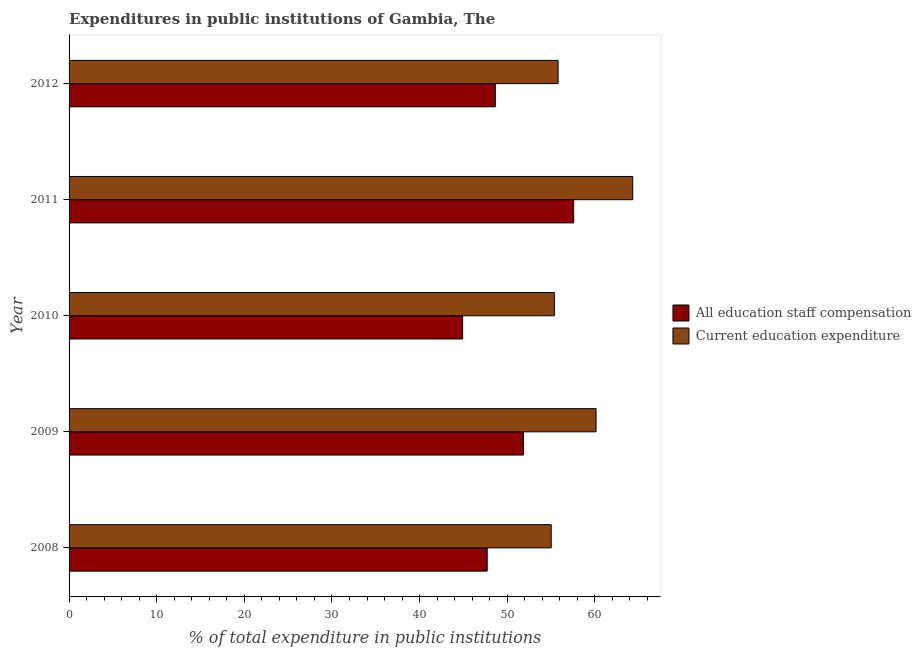How many different coloured bars are there?
Keep it short and to the point. 2. How many groups of bars are there?
Keep it short and to the point. 5. Are the number of bars per tick equal to the number of legend labels?
Ensure brevity in your answer.  Yes. Are the number of bars on each tick of the Y-axis equal?
Make the answer very short. Yes. How many bars are there on the 2nd tick from the top?
Your answer should be very brief. 2. How many bars are there on the 5th tick from the bottom?
Your answer should be compact. 2. In how many cases, is the number of bars for a given year not equal to the number of legend labels?
Ensure brevity in your answer.  0. What is the expenditure in staff compensation in 2010?
Offer a terse response. 44.91. Across all years, what is the maximum expenditure in education?
Offer a terse response. 64.33. Across all years, what is the minimum expenditure in staff compensation?
Your response must be concise. 44.91. In which year was the expenditure in staff compensation minimum?
Make the answer very short. 2010. What is the total expenditure in education in the graph?
Offer a very short reply. 290.68. What is the difference between the expenditure in education in 2008 and that in 2010?
Offer a terse response. -0.36. What is the difference between the expenditure in staff compensation in 2011 and the expenditure in education in 2012?
Your response must be concise. 1.78. What is the average expenditure in education per year?
Offer a terse response. 58.14. In the year 2008, what is the difference between the expenditure in education and expenditure in staff compensation?
Offer a terse response. 7.31. What is the ratio of the expenditure in education in 2009 to that in 2012?
Make the answer very short. 1.08. Is the expenditure in education in 2009 less than that in 2011?
Provide a succinct answer. Yes. Is the difference between the expenditure in staff compensation in 2008 and 2012 greater than the difference between the expenditure in education in 2008 and 2012?
Make the answer very short. No. What is the difference between the highest and the second highest expenditure in education?
Your response must be concise. 4.19. What is the difference between the highest and the lowest expenditure in staff compensation?
Offer a terse response. 12.67. In how many years, is the expenditure in education greater than the average expenditure in education taken over all years?
Your response must be concise. 2. Is the sum of the expenditure in education in 2010 and 2011 greater than the maximum expenditure in staff compensation across all years?
Provide a succinct answer. Yes. What does the 2nd bar from the top in 2008 represents?
Your response must be concise. All education staff compensation. What does the 2nd bar from the bottom in 2010 represents?
Make the answer very short. Current education expenditure. How many bars are there?
Keep it short and to the point. 10. Are all the bars in the graph horizontal?
Provide a short and direct response. Yes. How many years are there in the graph?
Your answer should be very brief. 5. What is the difference between two consecutive major ticks on the X-axis?
Ensure brevity in your answer.  10. Does the graph contain any zero values?
Your answer should be very brief. No. Does the graph contain grids?
Your response must be concise. No. Where does the legend appear in the graph?
Keep it short and to the point. Center right. How are the legend labels stacked?
Offer a very short reply. Vertical. What is the title of the graph?
Your answer should be very brief. Expenditures in public institutions of Gambia, The. What is the label or title of the X-axis?
Your answer should be very brief. % of total expenditure in public institutions. What is the % of total expenditure in public institutions in All education staff compensation in 2008?
Provide a succinct answer. 47.71. What is the % of total expenditure in public institutions in Current education expenditure in 2008?
Your response must be concise. 55.02. What is the % of total expenditure in public institutions in All education staff compensation in 2009?
Your response must be concise. 51.85. What is the % of total expenditure in public institutions of Current education expenditure in 2009?
Your response must be concise. 60.14. What is the % of total expenditure in public institutions in All education staff compensation in 2010?
Provide a succinct answer. 44.91. What is the % of total expenditure in public institutions in Current education expenditure in 2010?
Your response must be concise. 55.38. What is the % of total expenditure in public institutions of All education staff compensation in 2011?
Offer a terse response. 57.58. What is the % of total expenditure in public institutions of Current education expenditure in 2011?
Provide a succinct answer. 64.33. What is the % of total expenditure in public institutions of All education staff compensation in 2012?
Ensure brevity in your answer.  48.64. What is the % of total expenditure in public institutions in Current education expenditure in 2012?
Provide a short and direct response. 55.81. Across all years, what is the maximum % of total expenditure in public institutions in All education staff compensation?
Keep it short and to the point. 57.58. Across all years, what is the maximum % of total expenditure in public institutions of Current education expenditure?
Give a very brief answer. 64.33. Across all years, what is the minimum % of total expenditure in public institutions of All education staff compensation?
Make the answer very short. 44.91. Across all years, what is the minimum % of total expenditure in public institutions of Current education expenditure?
Offer a terse response. 55.02. What is the total % of total expenditure in public institutions of All education staff compensation in the graph?
Provide a succinct answer. 250.71. What is the total % of total expenditure in public institutions of Current education expenditure in the graph?
Offer a terse response. 290.68. What is the difference between the % of total expenditure in public institutions in All education staff compensation in 2008 and that in 2009?
Provide a short and direct response. -4.14. What is the difference between the % of total expenditure in public institutions in Current education expenditure in 2008 and that in 2009?
Offer a very short reply. -5.11. What is the difference between the % of total expenditure in public institutions in All education staff compensation in 2008 and that in 2010?
Your response must be concise. 2.8. What is the difference between the % of total expenditure in public institutions in Current education expenditure in 2008 and that in 2010?
Your answer should be compact. -0.36. What is the difference between the % of total expenditure in public institutions in All education staff compensation in 2008 and that in 2011?
Ensure brevity in your answer.  -9.87. What is the difference between the % of total expenditure in public institutions of Current education expenditure in 2008 and that in 2011?
Offer a very short reply. -9.3. What is the difference between the % of total expenditure in public institutions in All education staff compensation in 2008 and that in 2012?
Make the answer very short. -0.93. What is the difference between the % of total expenditure in public institutions of Current education expenditure in 2008 and that in 2012?
Your response must be concise. -0.78. What is the difference between the % of total expenditure in public institutions in All education staff compensation in 2009 and that in 2010?
Offer a terse response. 6.94. What is the difference between the % of total expenditure in public institutions of Current education expenditure in 2009 and that in 2010?
Ensure brevity in your answer.  4.75. What is the difference between the % of total expenditure in public institutions of All education staff compensation in 2009 and that in 2011?
Your answer should be compact. -5.73. What is the difference between the % of total expenditure in public institutions in Current education expenditure in 2009 and that in 2011?
Your answer should be compact. -4.19. What is the difference between the % of total expenditure in public institutions in All education staff compensation in 2009 and that in 2012?
Offer a terse response. 3.21. What is the difference between the % of total expenditure in public institutions in Current education expenditure in 2009 and that in 2012?
Offer a very short reply. 4.33. What is the difference between the % of total expenditure in public institutions of All education staff compensation in 2010 and that in 2011?
Keep it short and to the point. -12.67. What is the difference between the % of total expenditure in public institutions of Current education expenditure in 2010 and that in 2011?
Your answer should be compact. -8.94. What is the difference between the % of total expenditure in public institutions of All education staff compensation in 2010 and that in 2012?
Your response must be concise. -3.73. What is the difference between the % of total expenditure in public institutions of Current education expenditure in 2010 and that in 2012?
Your answer should be compact. -0.42. What is the difference between the % of total expenditure in public institutions of All education staff compensation in 2011 and that in 2012?
Offer a terse response. 8.94. What is the difference between the % of total expenditure in public institutions of Current education expenditure in 2011 and that in 2012?
Your answer should be very brief. 8.52. What is the difference between the % of total expenditure in public institutions of All education staff compensation in 2008 and the % of total expenditure in public institutions of Current education expenditure in 2009?
Offer a very short reply. -12.42. What is the difference between the % of total expenditure in public institutions in All education staff compensation in 2008 and the % of total expenditure in public institutions in Current education expenditure in 2010?
Provide a succinct answer. -7.67. What is the difference between the % of total expenditure in public institutions of All education staff compensation in 2008 and the % of total expenditure in public institutions of Current education expenditure in 2011?
Give a very brief answer. -16.61. What is the difference between the % of total expenditure in public institutions of All education staff compensation in 2008 and the % of total expenditure in public institutions of Current education expenditure in 2012?
Your answer should be very brief. -8.09. What is the difference between the % of total expenditure in public institutions of All education staff compensation in 2009 and the % of total expenditure in public institutions of Current education expenditure in 2010?
Ensure brevity in your answer.  -3.53. What is the difference between the % of total expenditure in public institutions in All education staff compensation in 2009 and the % of total expenditure in public institutions in Current education expenditure in 2011?
Offer a very short reply. -12.47. What is the difference between the % of total expenditure in public institutions of All education staff compensation in 2009 and the % of total expenditure in public institutions of Current education expenditure in 2012?
Offer a very short reply. -3.95. What is the difference between the % of total expenditure in public institutions in All education staff compensation in 2010 and the % of total expenditure in public institutions in Current education expenditure in 2011?
Provide a short and direct response. -19.42. What is the difference between the % of total expenditure in public institutions of All education staff compensation in 2010 and the % of total expenditure in public institutions of Current education expenditure in 2012?
Provide a succinct answer. -10.9. What is the difference between the % of total expenditure in public institutions of All education staff compensation in 2011 and the % of total expenditure in public institutions of Current education expenditure in 2012?
Offer a very short reply. 1.78. What is the average % of total expenditure in public institutions in All education staff compensation per year?
Make the answer very short. 50.14. What is the average % of total expenditure in public institutions of Current education expenditure per year?
Keep it short and to the point. 58.14. In the year 2008, what is the difference between the % of total expenditure in public institutions of All education staff compensation and % of total expenditure in public institutions of Current education expenditure?
Make the answer very short. -7.31. In the year 2009, what is the difference between the % of total expenditure in public institutions in All education staff compensation and % of total expenditure in public institutions in Current education expenditure?
Offer a very short reply. -8.28. In the year 2010, what is the difference between the % of total expenditure in public institutions of All education staff compensation and % of total expenditure in public institutions of Current education expenditure?
Your response must be concise. -10.47. In the year 2011, what is the difference between the % of total expenditure in public institutions of All education staff compensation and % of total expenditure in public institutions of Current education expenditure?
Your response must be concise. -6.74. In the year 2012, what is the difference between the % of total expenditure in public institutions of All education staff compensation and % of total expenditure in public institutions of Current education expenditure?
Your response must be concise. -7.16. What is the ratio of the % of total expenditure in public institutions in All education staff compensation in 2008 to that in 2009?
Give a very brief answer. 0.92. What is the ratio of the % of total expenditure in public institutions of Current education expenditure in 2008 to that in 2009?
Your response must be concise. 0.92. What is the ratio of the % of total expenditure in public institutions in All education staff compensation in 2008 to that in 2010?
Your answer should be very brief. 1.06. What is the ratio of the % of total expenditure in public institutions of All education staff compensation in 2008 to that in 2011?
Keep it short and to the point. 0.83. What is the ratio of the % of total expenditure in public institutions of Current education expenditure in 2008 to that in 2011?
Provide a short and direct response. 0.86. What is the ratio of the % of total expenditure in public institutions in All education staff compensation in 2008 to that in 2012?
Your answer should be compact. 0.98. What is the ratio of the % of total expenditure in public institutions of All education staff compensation in 2009 to that in 2010?
Your response must be concise. 1.15. What is the ratio of the % of total expenditure in public institutions in Current education expenditure in 2009 to that in 2010?
Ensure brevity in your answer.  1.09. What is the ratio of the % of total expenditure in public institutions of All education staff compensation in 2009 to that in 2011?
Your answer should be compact. 0.9. What is the ratio of the % of total expenditure in public institutions of Current education expenditure in 2009 to that in 2011?
Provide a short and direct response. 0.93. What is the ratio of the % of total expenditure in public institutions in All education staff compensation in 2009 to that in 2012?
Give a very brief answer. 1.07. What is the ratio of the % of total expenditure in public institutions of Current education expenditure in 2009 to that in 2012?
Give a very brief answer. 1.08. What is the ratio of the % of total expenditure in public institutions of All education staff compensation in 2010 to that in 2011?
Give a very brief answer. 0.78. What is the ratio of the % of total expenditure in public institutions of Current education expenditure in 2010 to that in 2011?
Provide a short and direct response. 0.86. What is the ratio of the % of total expenditure in public institutions of All education staff compensation in 2010 to that in 2012?
Give a very brief answer. 0.92. What is the ratio of the % of total expenditure in public institutions of All education staff compensation in 2011 to that in 2012?
Provide a succinct answer. 1.18. What is the ratio of the % of total expenditure in public institutions of Current education expenditure in 2011 to that in 2012?
Your answer should be compact. 1.15. What is the difference between the highest and the second highest % of total expenditure in public institutions of All education staff compensation?
Ensure brevity in your answer.  5.73. What is the difference between the highest and the second highest % of total expenditure in public institutions of Current education expenditure?
Provide a short and direct response. 4.19. What is the difference between the highest and the lowest % of total expenditure in public institutions of All education staff compensation?
Keep it short and to the point. 12.67. What is the difference between the highest and the lowest % of total expenditure in public institutions of Current education expenditure?
Offer a terse response. 9.3. 